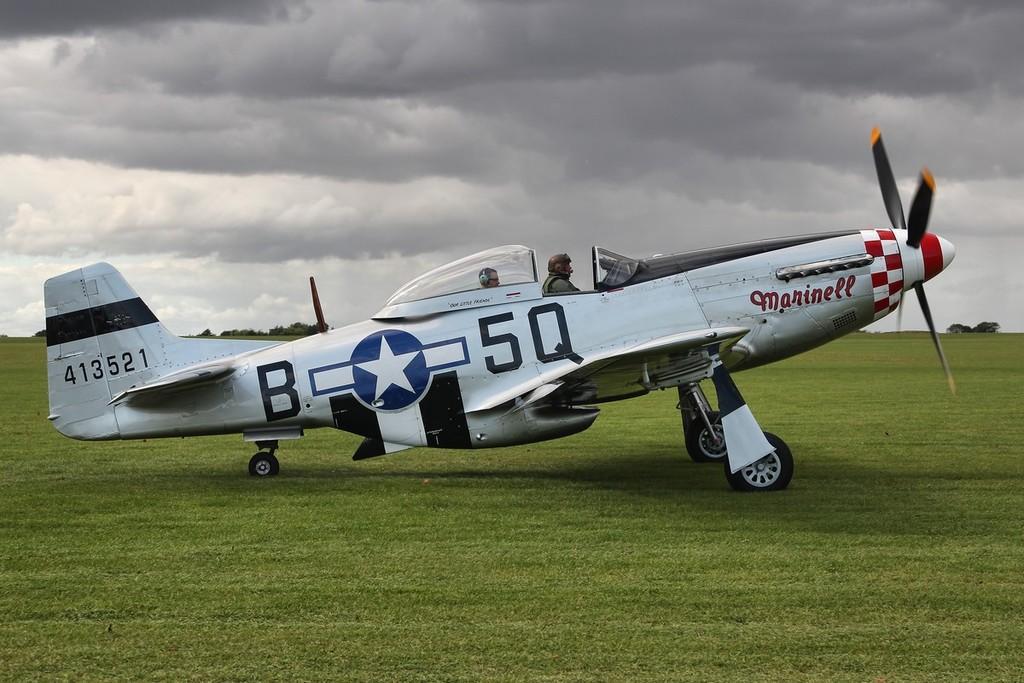How would you summarize this image in a sentence or two? In the image there is an aeroplane on the grassland with two men sitting in it and in the background there are trees on the right and left side and above its sky with clouds. 